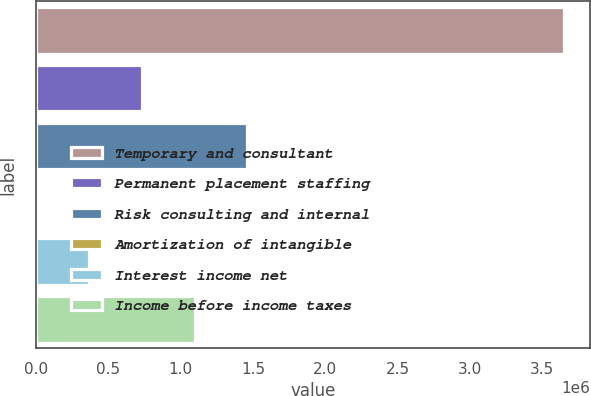Convert chart to OTSL. <chart><loc_0><loc_0><loc_500><loc_500><bar_chart><fcel>Temporary and consultant<fcel>Permanent placement staffing<fcel>Risk consulting and internal<fcel>Amortization of intangible<fcel>Interest income net<fcel>Income before income taxes<nl><fcel>3.64927e+06<fcel>731930<fcel>1.46127e+06<fcel>2594<fcel>367262<fcel>1.0966e+06<nl></chart> 